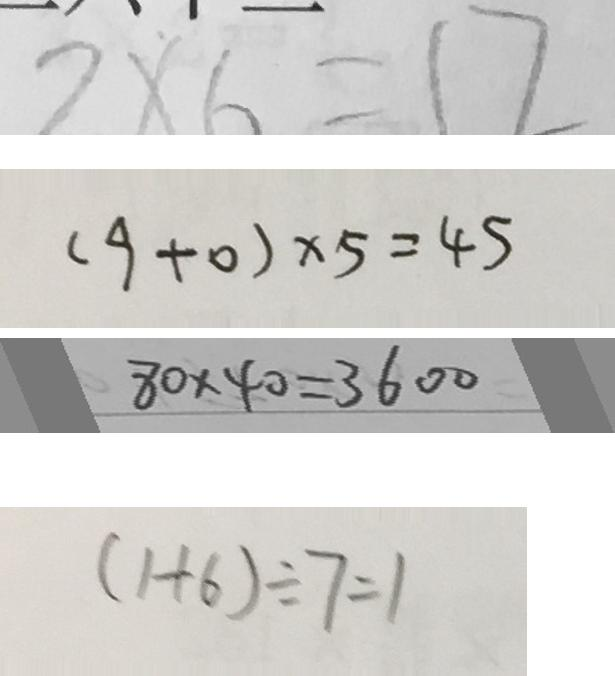Convert formula to latex. <formula><loc_0><loc_0><loc_500><loc_500>2 \times 6 = 1 2 
 ( 9 + 0 ) \times 5 = 4 5 
 8 0 \times 4 0 = 3 6 0 0 
 ( 1 + 6 ) \div 7 = 1</formula> 